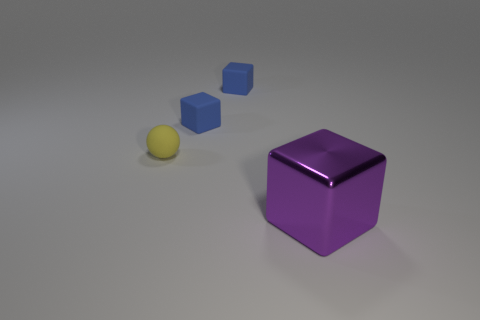Can you describe the colors of the objects shown in the image? Certainly! In the image, there are two distinct objects, each with their own unique color. The cube in the foreground has a vibrant purple hue with a somewhat reflective surface, while the smaller cubes in the background are a uniform shade of blue. The tiny rubber ball, although not directly asked about, is a muted yellow. 